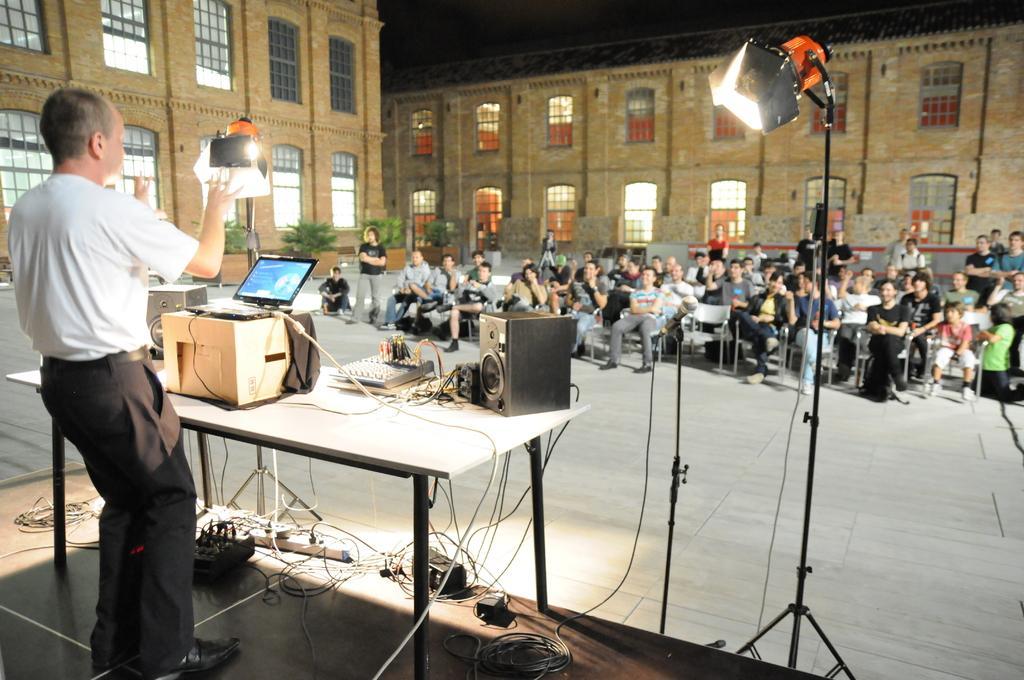Describe this image in one or two sentences. A place where group of people sitting on the chairs and some are standing are in front of a person who is standing and has a table in front of him on which there are some items like speaker and laptop and there are two buildings around them. 